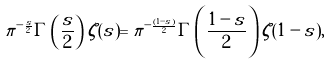Convert formula to latex. <formula><loc_0><loc_0><loc_500><loc_500>\pi ^ { - \frac { s } { 2 } } \Gamma \left ( \frac { s } { 2 } \right ) \zeta ( s ) = \pi ^ { - \frac { ( 1 - s ) } { 2 } } \Gamma \left ( \frac { 1 - s } { 2 } \right ) \zeta ( 1 - s ) ,</formula> 